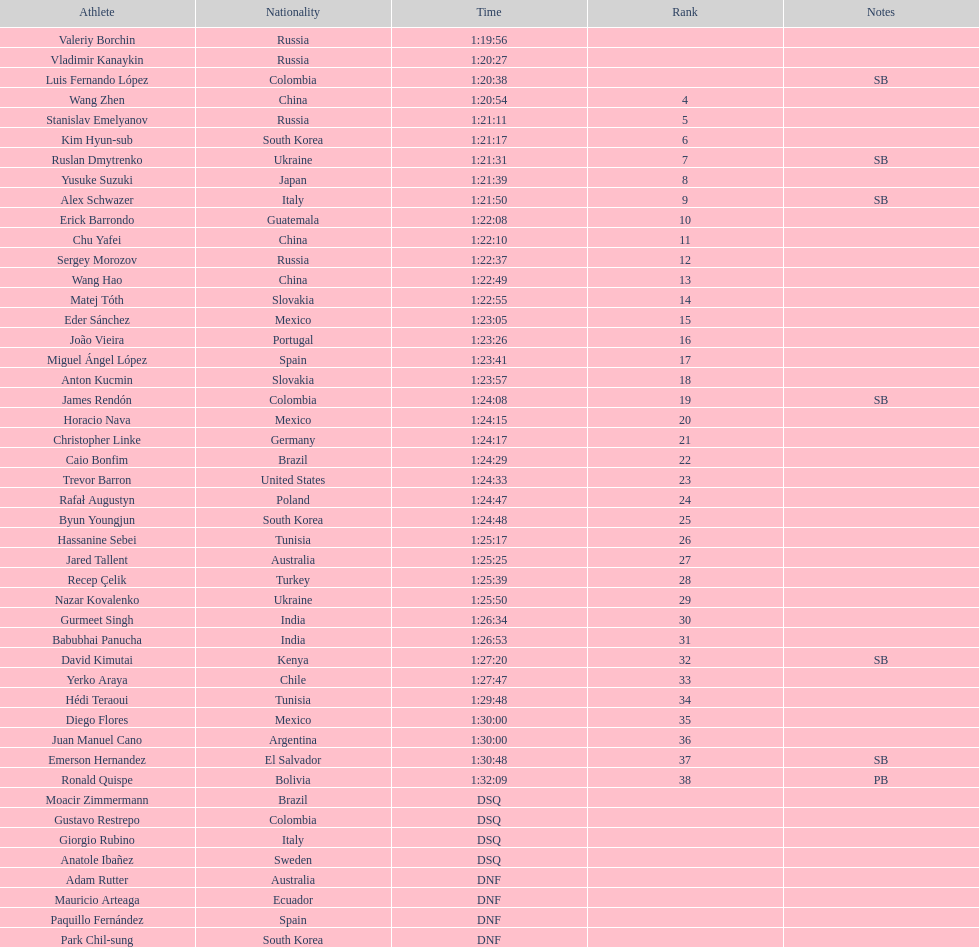Which competitor was ranked first? Valeriy Borchin. 